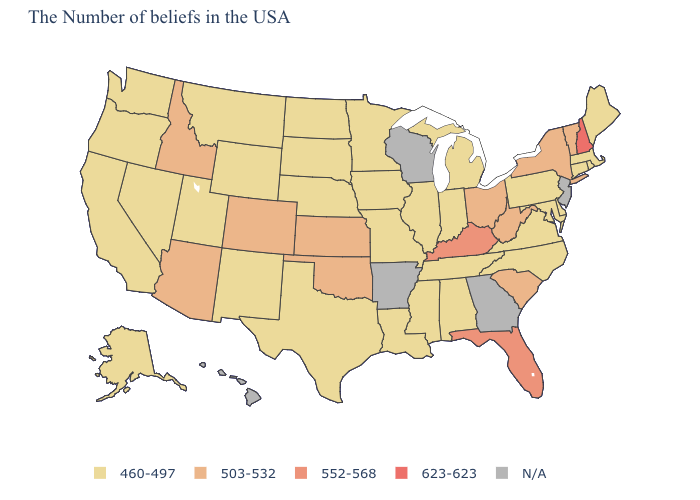What is the highest value in states that border Michigan?
Short answer required. 503-532. Does the first symbol in the legend represent the smallest category?
Give a very brief answer. Yes. Is the legend a continuous bar?
Concise answer only. No. Which states have the lowest value in the Northeast?
Be succinct. Maine, Massachusetts, Rhode Island, Connecticut, Pennsylvania. How many symbols are there in the legend?
Quick response, please. 5. What is the value of California?
Answer briefly. 460-497. What is the value of Kentucky?
Give a very brief answer. 552-568. What is the highest value in states that border Oklahoma?
Answer briefly. 503-532. Does New York have the lowest value in the USA?
Answer briefly. No. Does Maine have the highest value in the USA?
Keep it brief. No. Among the states that border Mississippi , which have the lowest value?
Keep it brief. Alabama, Tennessee, Louisiana. Which states have the lowest value in the USA?
Keep it brief. Maine, Massachusetts, Rhode Island, Connecticut, Delaware, Maryland, Pennsylvania, Virginia, North Carolina, Michigan, Indiana, Alabama, Tennessee, Illinois, Mississippi, Louisiana, Missouri, Minnesota, Iowa, Nebraska, Texas, South Dakota, North Dakota, Wyoming, New Mexico, Utah, Montana, Nevada, California, Washington, Oregon, Alaska. Name the states that have a value in the range 503-532?
Concise answer only. Vermont, New York, South Carolina, West Virginia, Ohio, Kansas, Oklahoma, Colorado, Arizona, Idaho. Name the states that have a value in the range 503-532?
Keep it brief. Vermont, New York, South Carolina, West Virginia, Ohio, Kansas, Oklahoma, Colorado, Arizona, Idaho. What is the value of Vermont?
Short answer required. 503-532. 